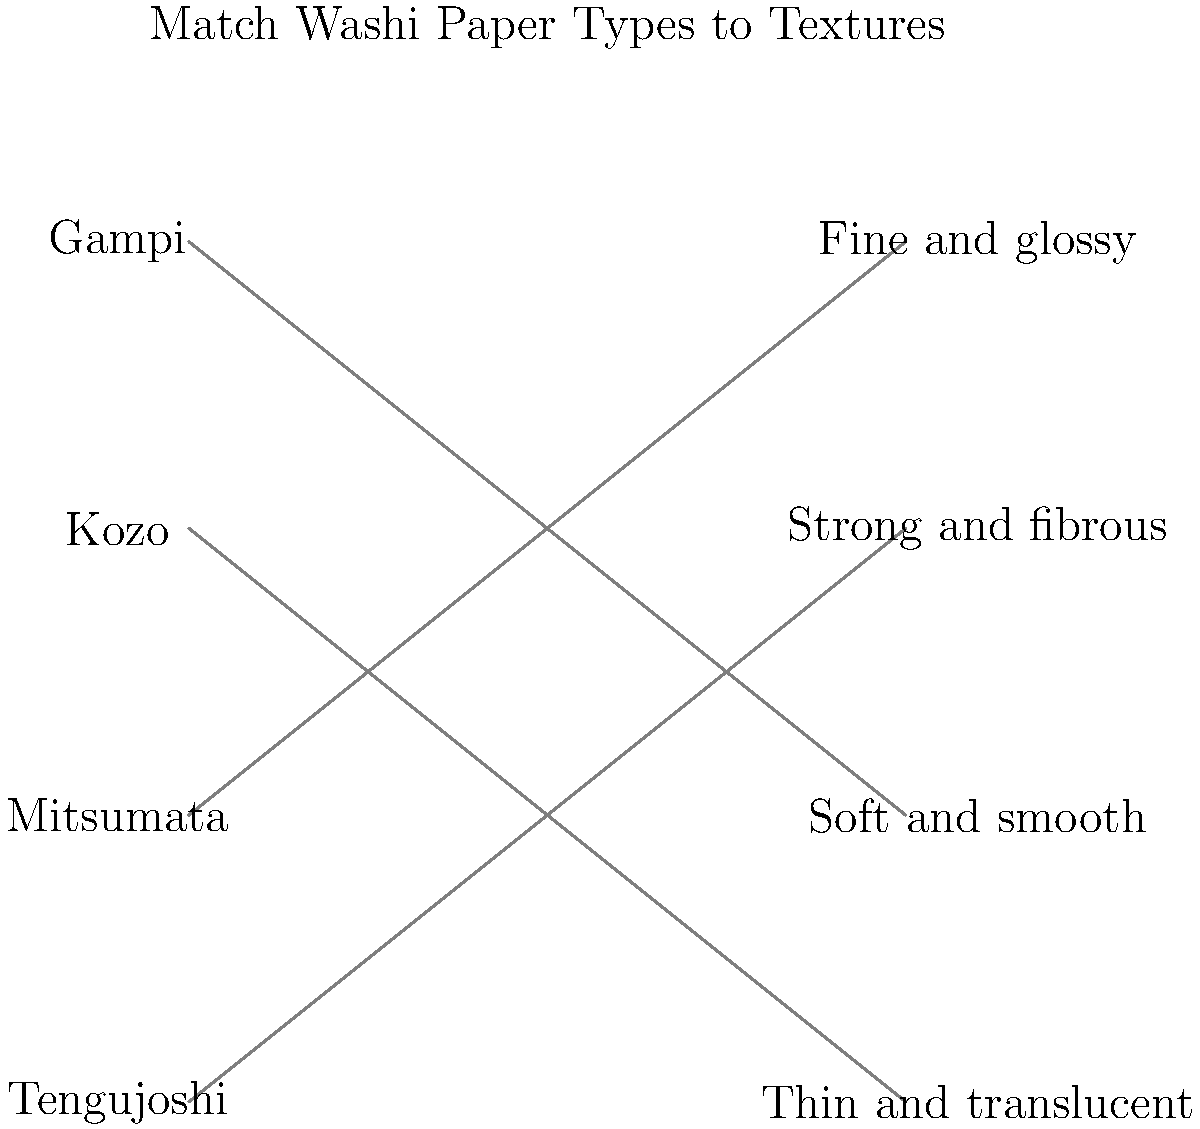Match the following types of washi paper to their corresponding textures and patterns:

1. Gampi
2. Kozo
3. Mitsumata
4. Tengujoshi

A. Thin and translucent
B. Strong and fibrous
C. Fine and glossy
D. Soft and smooth To match the washi paper types to their corresponding textures and patterns, let's consider each type:

1. Gampi:
   - Known for its smooth surface and natural luster
   - Texture: Fine and glossy
   - Match: C

2. Kozo:
   - Made from mulberry bark, known for its strength
   - Texture: Strong and fibrous
   - Match: B

3. Mitsumata:
   - Prized for its softness and smooth texture
   - Texture: Soft and smooth
   - Match: D

4. Tengujoshi:
   - A delicate and lightweight paper
   - Texture: Thin and translucent
   - Match: A

By understanding the unique characteristics of each washi paper type, we can correctly match them to their corresponding textures and patterns.
Answer: 1-C, 2-B, 3-D, 4-A 